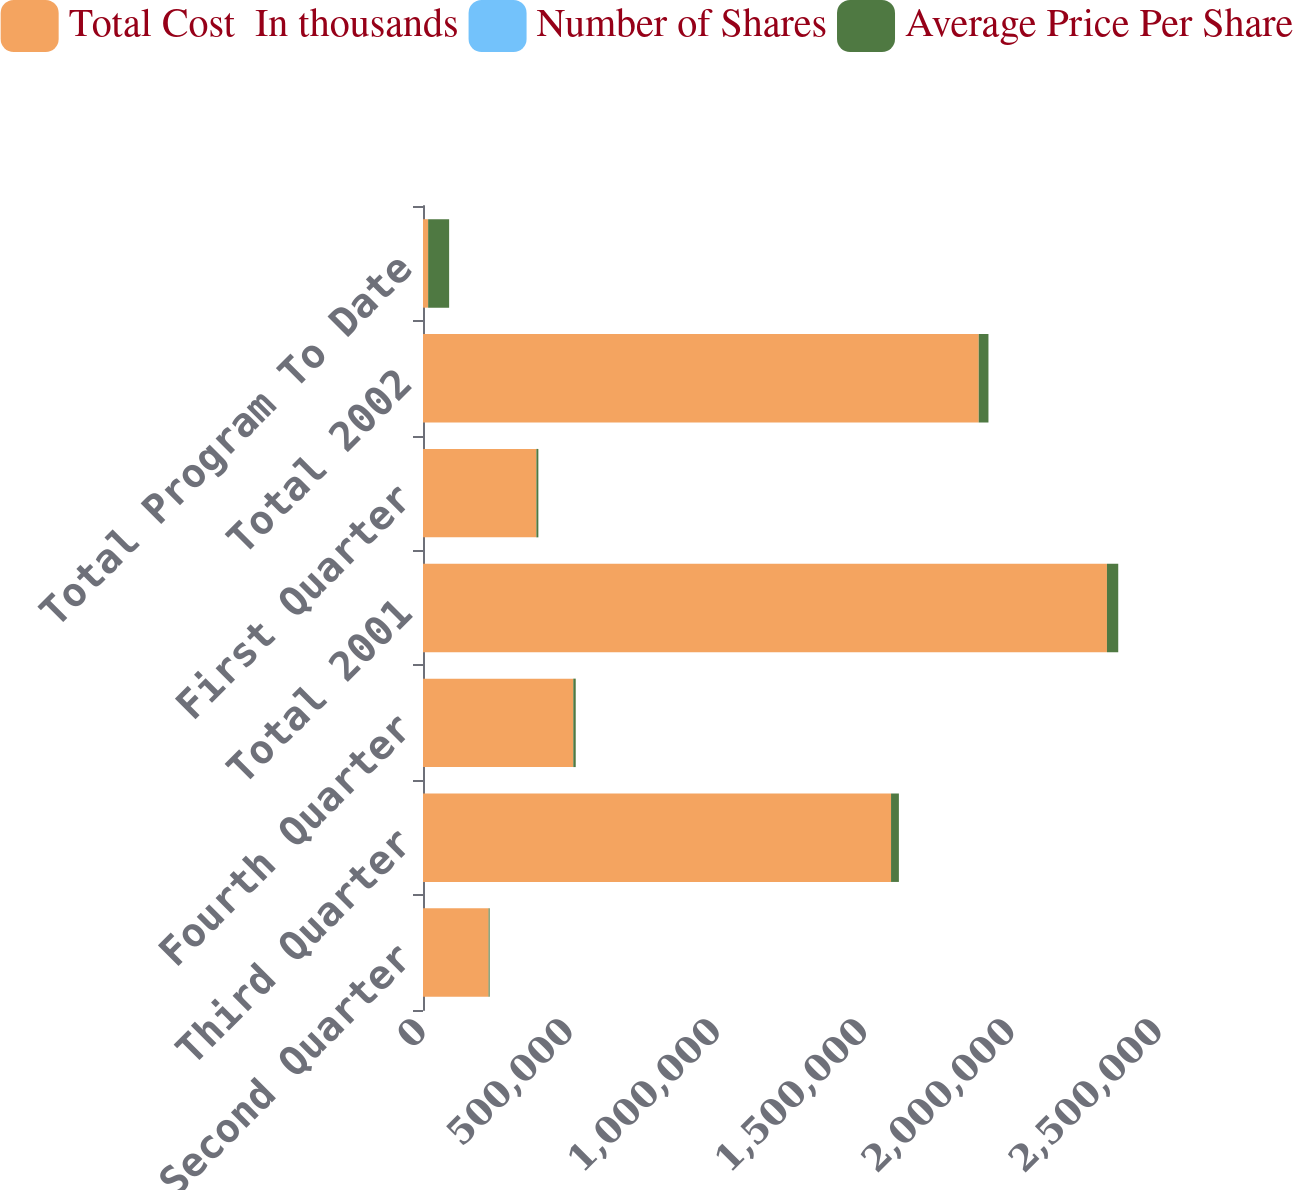Convert chart. <chart><loc_0><loc_0><loc_500><loc_500><stacked_bar_chart><ecel><fcel>Second Quarter<fcel>Third Quarter<fcel>Fourth Quarter<fcel>Total 2001<fcel>First Quarter<fcel>Total 2002<fcel>Total Program To Date<nl><fcel>Total Cost  In thousands<fcel>222900<fcel>1.5898e+06<fcel>510500<fcel>2.3232e+06<fcel>385100<fcel>1.8877e+06<fcel>17431.5<nl><fcel>Number of Shares<fcel>15.55<fcel>16.75<fcel>16.12<fcel>16.5<fcel>17.54<fcel>17.47<fcel>16.94<nl><fcel>Average Price Per Share<fcel>3465<fcel>26634<fcel>8229<fcel>38328<fcel>6754<fcel>32987<fcel>71315<nl></chart> 